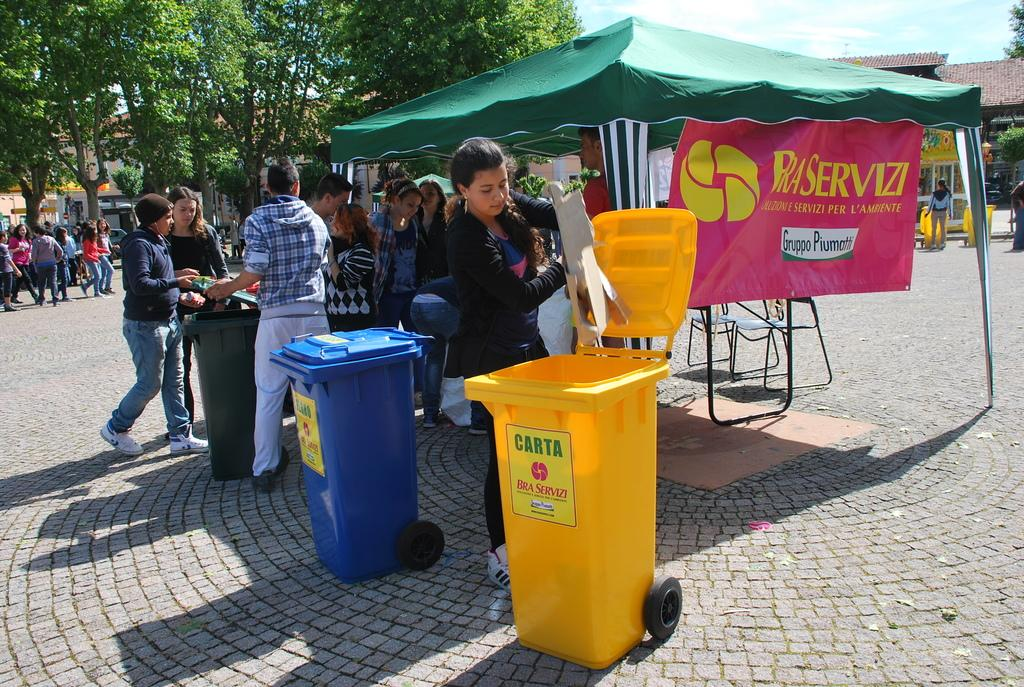<image>
Write a terse but informative summary of the picture. A woman empties some trash into the Bra Servizi trash can. 